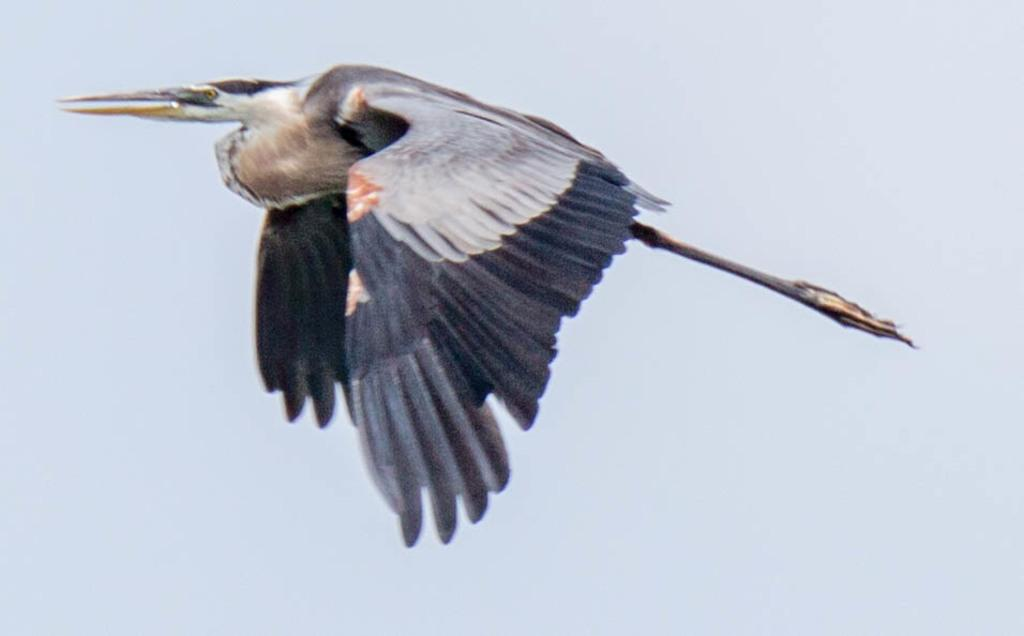What is happening in the sky in the image? There is a bird flying in the sky. What is the condition of the sky in the image? The sky appears cloudy. What type of rod can be seen in the image? There is no rod present in the image; it features a bird flying in a cloudy sky. 